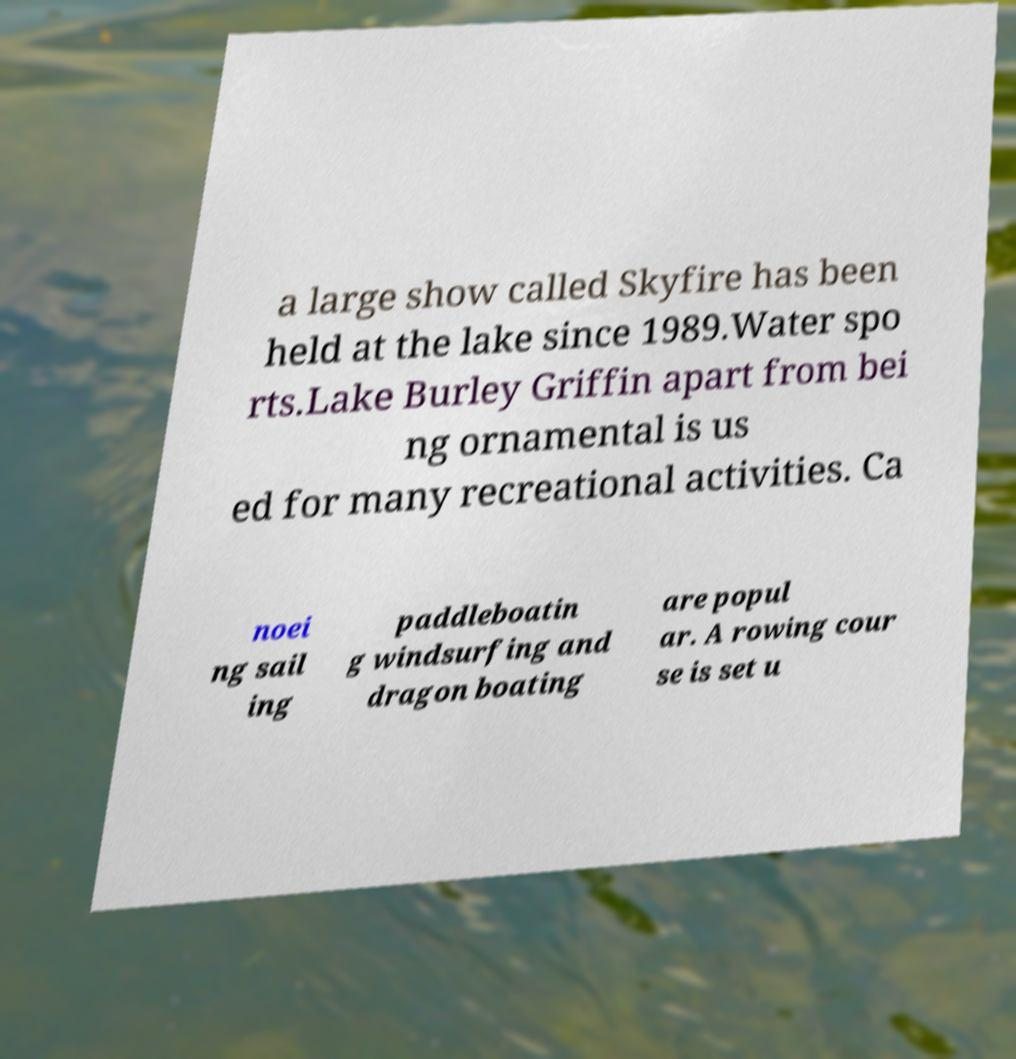For documentation purposes, I need the text within this image transcribed. Could you provide that? a large show called Skyfire has been held at the lake since 1989.Water spo rts.Lake Burley Griffin apart from bei ng ornamental is us ed for many recreational activities. Ca noei ng sail ing paddleboatin g windsurfing and dragon boating are popul ar. A rowing cour se is set u 